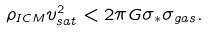Convert formula to latex. <formula><loc_0><loc_0><loc_500><loc_500>\rho _ { I C M } v _ { s a t } ^ { 2 } < 2 \pi G \sigma _ { \ast } \sigma _ { g a s } .</formula> 